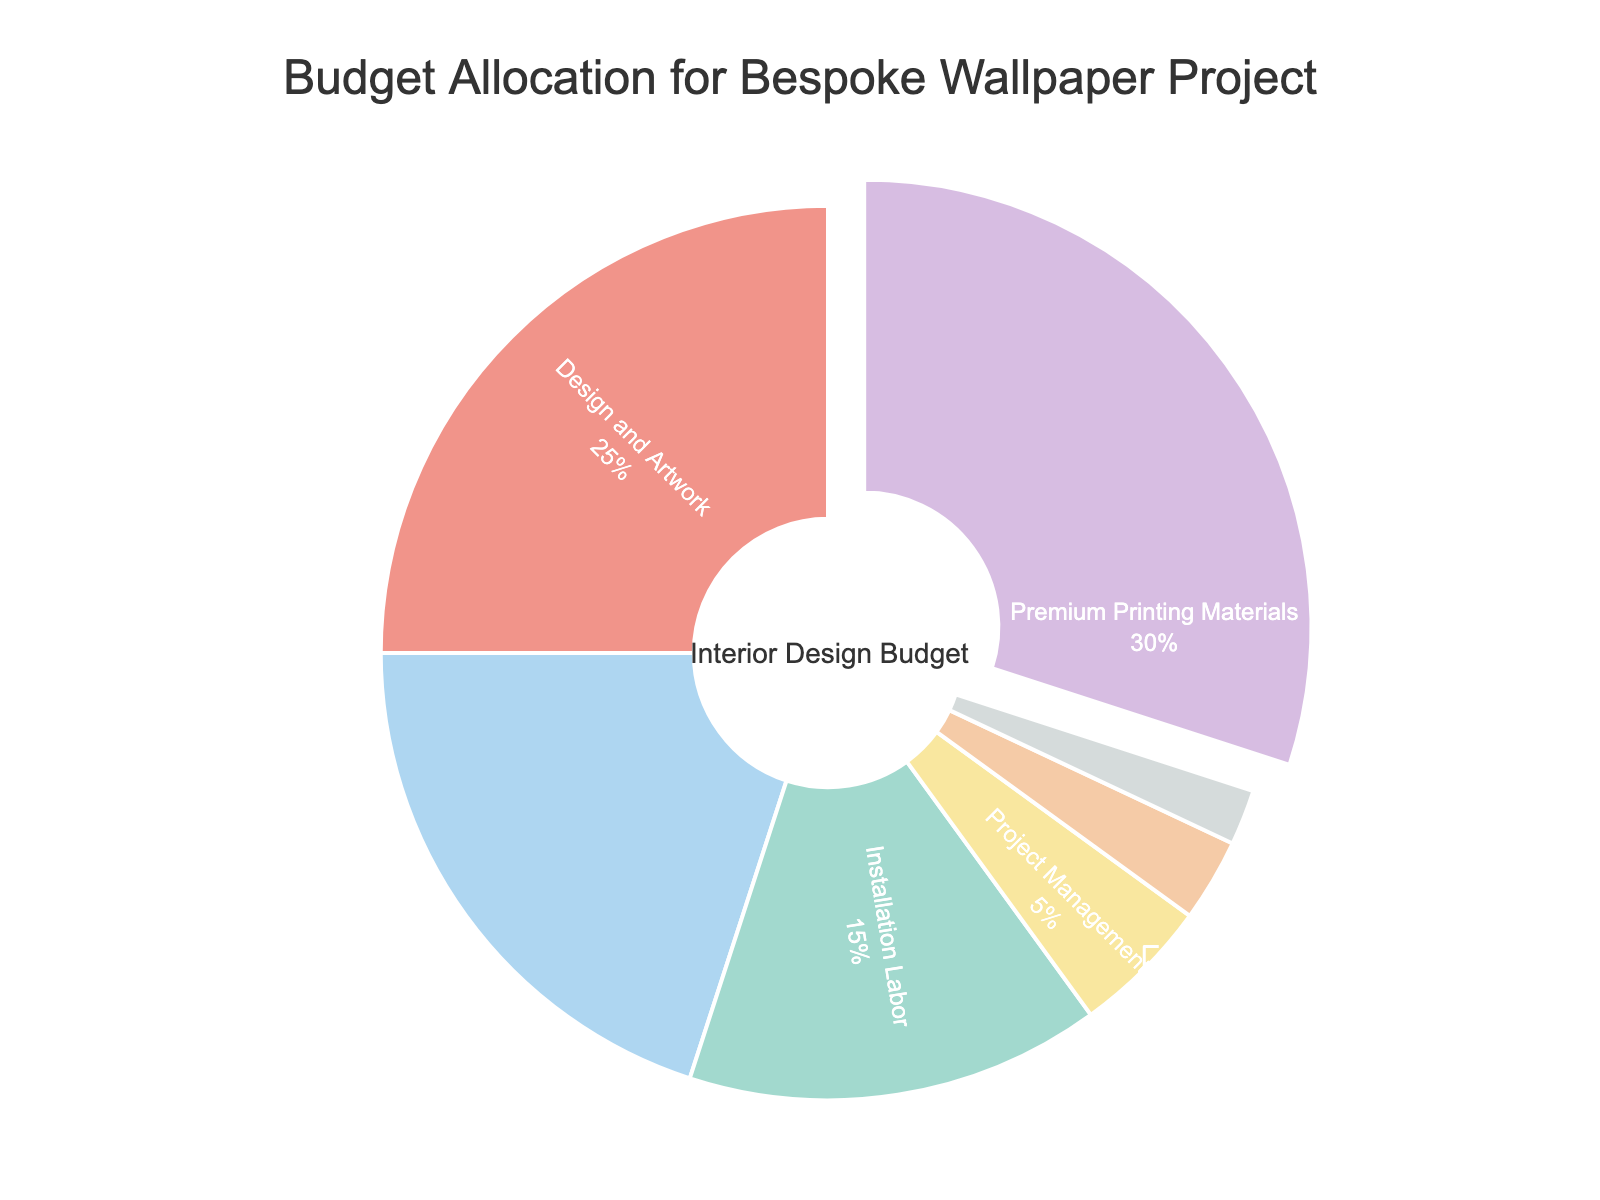What is the largest budget component in the pie chart? The largest segment of the pie chart, which is pulled out slightly, represents the "Premium Printing Materials".
Answer: Premium Printing Materials What percentage of the budget is allocated to Design and Artwork and Sample Production combined? Design and Artwork is 25% and Sample Production is 2%. Adding them together: 25% + 2% = 27%.
Answer: 27% Which budget component has the smallest allocation? The smallest segment in the pie chart is "Sample Production" at 2%.
Answer: Sample Production How much larger is the percentage allocated to Professional Printing Services compared to Project Management? Professional Printing Services is 20%, while Project Management is 5%. To find how much larger, subtract the smaller percentage from the larger percentage: 20% - 5% = 15%.
Answer: 15% If the budget for Installation Labor and Shipping and Handling are combined, what is their total allocation? Installation Labor is 15% and Shipping and Handling is 3%. Adding them together: 15% + 3% = 18%.
Answer: 18% What can you infer about the budget allocation towards Installation Labor versus Project Management? Installation Labor is allocated 15%, which is significantly larger compared to the 5% allocated to Project Management.
Answer: Installation Labor is significantly larger What percentage of the budget is not allocated to Premium Printing Materials? Premium Printing Materials takes up 30% of the budget. The total budget is 100%, so subtracting 30% from 100% gives us 100% - 30% = 70%.
Answer: 70% Which color corresponds to the Professional Printing Services segment in the pie chart? The segment labeled "Professional Printing Services" in the pie chart is assigned a specific color for distinction. In this case, it is blue.
Answer: Blue What is the cumulative percentage of budget allocated to Premium Printing Materials, Professional Printing Services, and Installation Labor? Premium Printing Materials is 30%, Professional Printing Services is 20%, and Installation Labor is 15%. Adding these together: 30% + 20% + 15% = 65%.
Answer: 65% How does the allocation for Shipping and Handling compare with the allocation for Sample Production? Shipping and Handling is 3% of the budget, while Sample Production is 2%. Shipping and Handling is slightly higher by 1%.
Answer: Shipping and Handling is 1% higher 